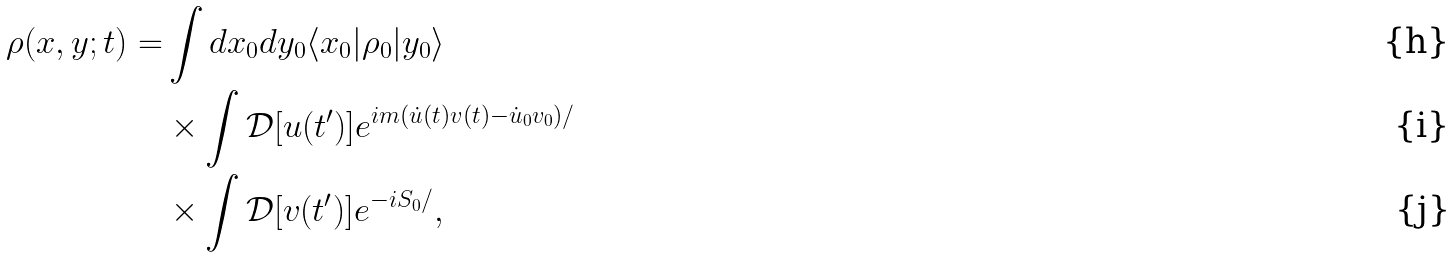Convert formula to latex. <formula><loc_0><loc_0><loc_500><loc_500>\rho ( x , y ; t ) = & \int d x _ { 0 } d y _ { 0 } \langle x _ { 0 } | \rho _ { 0 } | y _ { 0 } \rangle \\ & \times \int \mathcal { D } [ u ( t ^ { \prime } ) ] e ^ { i m ( \dot { u } ( t ) v ( t ) - \dot { u } _ { 0 } v _ { 0 } ) / } \\ & \times \int \mathcal { D } [ v ( t ^ { \prime } ) ] e ^ { - i S _ { 0 } / } ,</formula> 